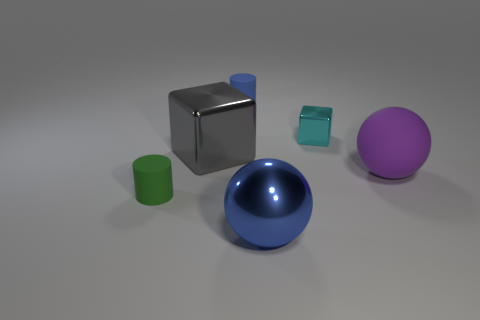What materials do the objects in the image appear to be made of? The objects in the image appear to be made of different materials with varying finishes. The large purple sphere has a matte finish, suggesting a surface that diffuses light. The blue cube and small green cylinder have a bit of shine, indicating a likely plastic or metallic material with a smoother surface. The second blue object, which is a sphere, seems to have a reflective surface, possibly made of polished metal or glass. 